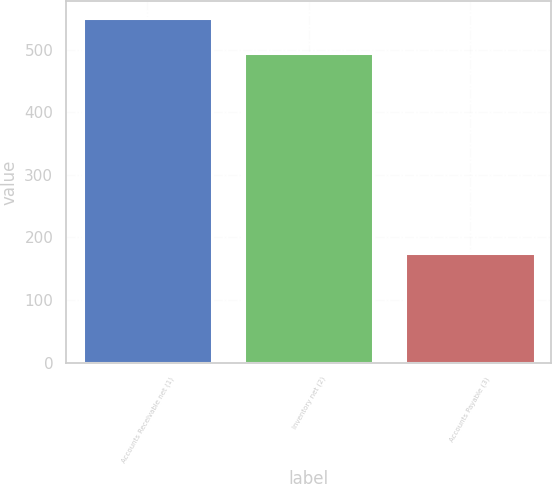Convert chart. <chart><loc_0><loc_0><loc_500><loc_500><bar_chart><fcel>Accounts Receivable net (1)<fcel>Inventory net (2)<fcel>Accounts Payable (3)<nl><fcel>550<fcel>495<fcel>175<nl></chart> 